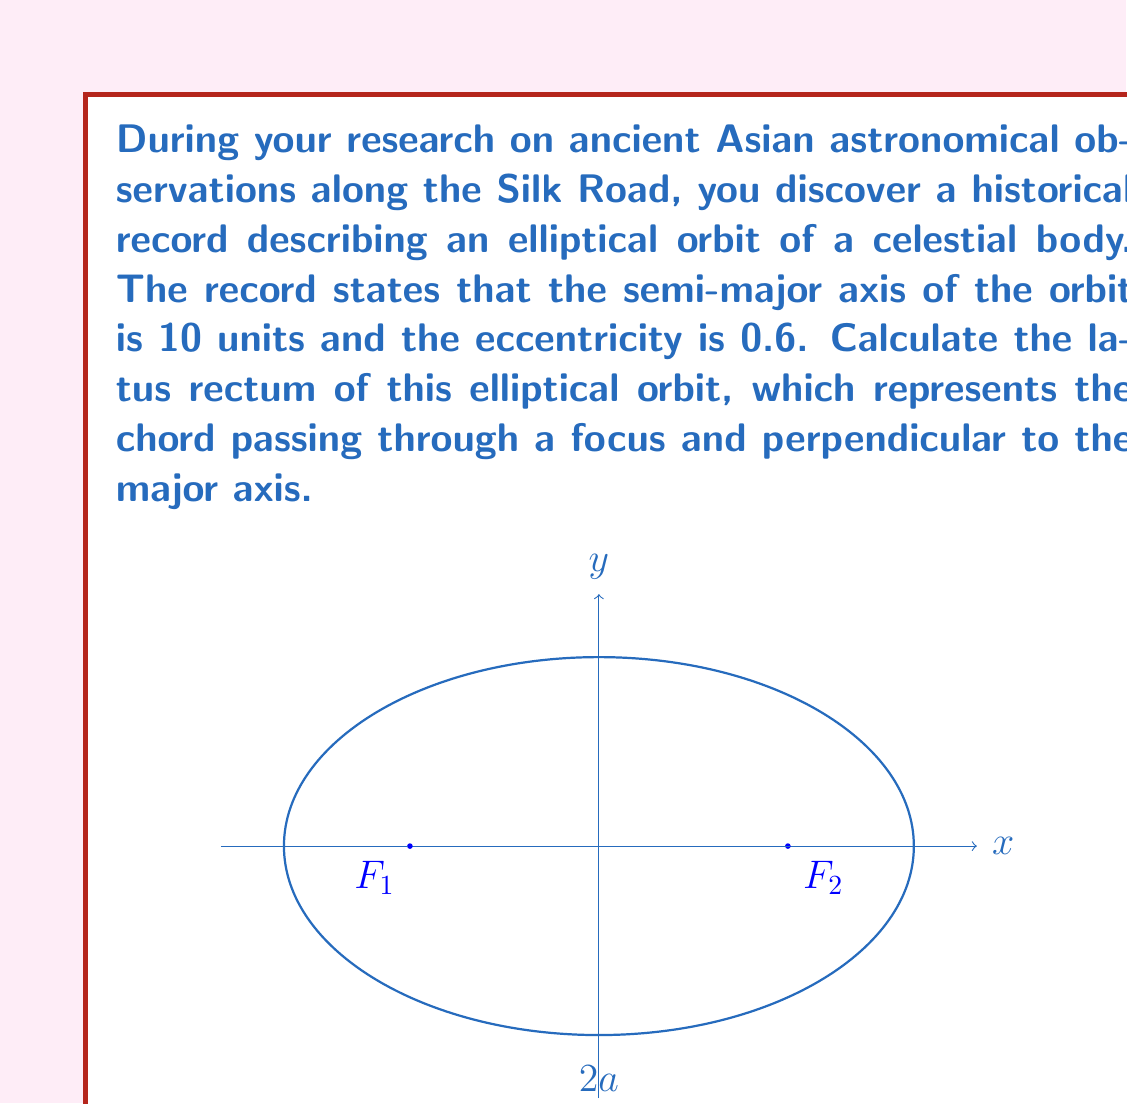Can you solve this math problem? Let's approach this step-by-step:

1) The latus rectum of an ellipse is given by the formula:

   $$ l = \frac{2b^2}{a} $$

   where $l$ is the latus rectum, $a$ is the semi-major axis, and $b$ is the semi-minor axis.

2) We're given that $a = 10$ and the eccentricity $e = 0.6$.

3) We need to find $b$. We can use the relationship between eccentricity, semi-major axis, and semi-minor axis:

   $$ e = \sqrt{1 - \frac{b^2}{a^2}} $$

4) Rearranging this equation:

   $$ b^2 = a^2(1 - e^2) $$

5) Substituting the known values:

   $$ b^2 = 10^2(1 - 0.6^2) = 100(1 - 0.36) = 100(0.64) = 64 $$

6) Therefore, $b = 8$.

7) Now we can substitute into the latus rectum formula:

   $$ l = \frac{2b^2}{a} = \frac{2(64)}{10} = \frac{128}{10} = 12.8 $$

Thus, the latus rectum of the elliptical orbit is 12.8 units.
Answer: $12.8$ units 